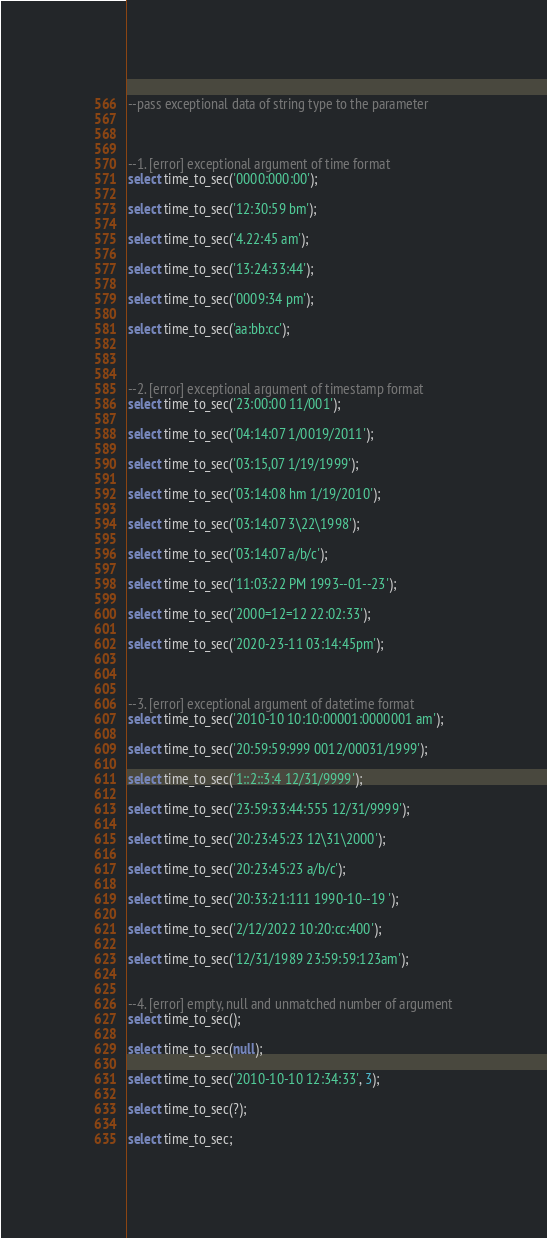Convert code to text. <code><loc_0><loc_0><loc_500><loc_500><_SQL_>--pass exceptional data of string type to the parameter



--1. [error] exceptional argument of time format
select time_to_sec('0000:000:00');

select time_to_sec('12:30:59 bm');

select time_to_sec('4.22:45 am');

select time_to_sec('13:24:33:44');

select time_to_sec('0009:34 pm');

select time_to_sec('aa:bb:cc');



--2. [error] exceptional argument of timestamp format
select time_to_sec('23:00:00 11/001');

select time_to_sec('04:14:07 1/0019/2011');

select time_to_sec('03:15,07 1/19/1999');

select time_to_sec('03:14:08 hm 1/19/2010');

select time_to_sec('03:14:07 3\22\1998');

select time_to_sec('03:14:07 a/b/c');

select time_to_sec('11:03:22 PM 1993--01--23');

select time_to_sec('2000=12=12 22:02:33');

select time_to_sec('2020-23-11 03:14:45pm');



--3. [error] exceptional argument of datetime format
select time_to_sec('2010-10 10:10:00001:0000001 am');

select time_to_sec('20:59:59:999 0012/00031/1999');

select time_to_sec('1::2::3:4 12/31/9999');

select time_to_sec('23:59:33:44:555 12/31/9999');

select time_to_sec('20:23:45:23 12\31\2000');

select time_to_sec('20:23:45:23 a/b/c');

select time_to_sec('20:33:21:111 1990-10--19 ');

select time_to_sec('2/12/2022 10:20:cc:400');

select time_to_sec('12/31/1989 23:59:59:123am');


--4. [error] empty, null and unmatched number of argument
select time_to_sec();

select time_to_sec(null);

select time_to_sec('2010-10-10 12:34:33', 3);

select time_to_sec(?);

select time_to_sec;
</code> 